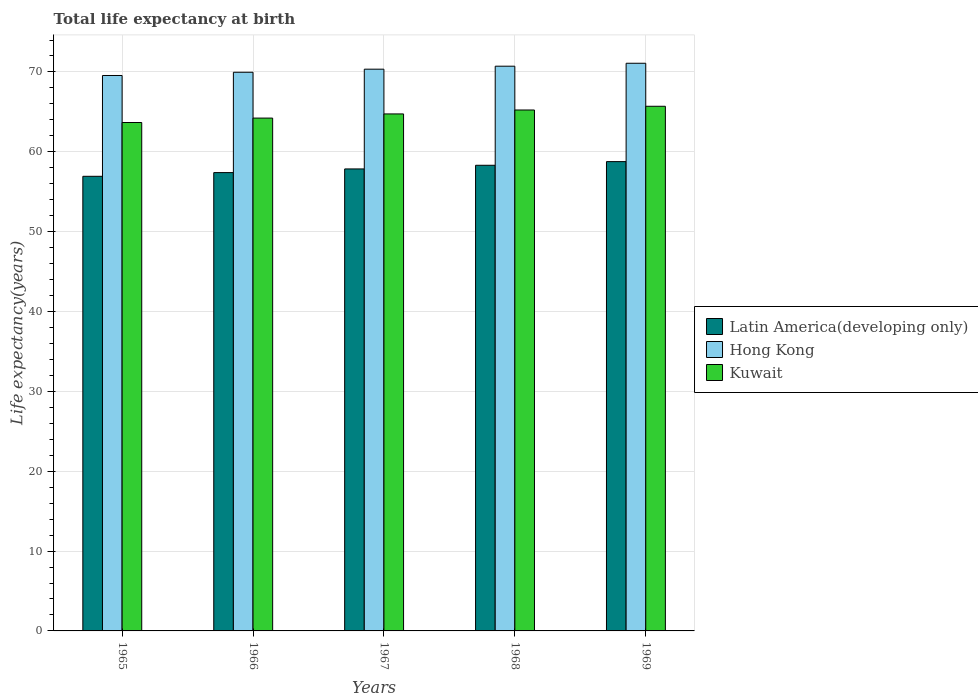How many different coloured bars are there?
Provide a succinct answer. 3. How many bars are there on the 2nd tick from the left?
Your response must be concise. 3. How many bars are there on the 5th tick from the right?
Provide a short and direct response. 3. What is the label of the 5th group of bars from the left?
Offer a terse response. 1969. What is the life expectancy at birth in in Kuwait in 1965?
Give a very brief answer. 63.67. Across all years, what is the maximum life expectancy at birth in in Kuwait?
Give a very brief answer. 65.7. Across all years, what is the minimum life expectancy at birth in in Hong Kong?
Make the answer very short. 69.56. In which year was the life expectancy at birth in in Hong Kong maximum?
Your answer should be compact. 1969. In which year was the life expectancy at birth in in Kuwait minimum?
Your answer should be very brief. 1965. What is the total life expectancy at birth in in Kuwait in the graph?
Keep it short and to the point. 323.57. What is the difference between the life expectancy at birth in in Kuwait in 1965 and that in 1969?
Keep it short and to the point. -2.03. What is the difference between the life expectancy at birth in in Hong Kong in 1968 and the life expectancy at birth in in Kuwait in 1969?
Ensure brevity in your answer.  5.02. What is the average life expectancy at birth in in Kuwait per year?
Provide a short and direct response. 64.71. In the year 1966, what is the difference between the life expectancy at birth in in Hong Kong and life expectancy at birth in in Kuwait?
Your answer should be very brief. 5.74. In how many years, is the life expectancy at birth in in Kuwait greater than 4 years?
Provide a succinct answer. 5. What is the ratio of the life expectancy at birth in in Latin America(developing only) in 1965 to that in 1969?
Provide a short and direct response. 0.97. Is the life expectancy at birth in in Hong Kong in 1967 less than that in 1968?
Provide a short and direct response. Yes. What is the difference between the highest and the second highest life expectancy at birth in in Kuwait?
Provide a short and direct response. 0.47. What is the difference between the highest and the lowest life expectancy at birth in in Latin America(developing only)?
Your response must be concise. 1.84. In how many years, is the life expectancy at birth in in Kuwait greater than the average life expectancy at birth in in Kuwait taken over all years?
Offer a very short reply. 3. Is the sum of the life expectancy at birth in in Latin America(developing only) in 1965 and 1967 greater than the maximum life expectancy at birth in in Hong Kong across all years?
Your response must be concise. Yes. What does the 1st bar from the left in 1968 represents?
Keep it short and to the point. Latin America(developing only). What does the 1st bar from the right in 1968 represents?
Provide a succinct answer. Kuwait. Is it the case that in every year, the sum of the life expectancy at birth in in Latin America(developing only) and life expectancy at birth in in Hong Kong is greater than the life expectancy at birth in in Kuwait?
Your response must be concise. Yes. Are all the bars in the graph horizontal?
Give a very brief answer. No. How many years are there in the graph?
Make the answer very short. 5. Are the values on the major ticks of Y-axis written in scientific E-notation?
Give a very brief answer. No. How many legend labels are there?
Offer a very short reply. 3. How are the legend labels stacked?
Your answer should be compact. Vertical. What is the title of the graph?
Make the answer very short. Total life expectancy at birth. What is the label or title of the X-axis?
Offer a terse response. Years. What is the label or title of the Y-axis?
Your answer should be compact. Life expectancy(years). What is the Life expectancy(years) in Latin America(developing only) in 1965?
Your answer should be compact. 56.93. What is the Life expectancy(years) of Hong Kong in 1965?
Ensure brevity in your answer.  69.56. What is the Life expectancy(years) of Kuwait in 1965?
Ensure brevity in your answer.  63.67. What is the Life expectancy(years) of Latin America(developing only) in 1966?
Provide a short and direct response. 57.39. What is the Life expectancy(years) of Hong Kong in 1966?
Give a very brief answer. 69.96. What is the Life expectancy(years) of Kuwait in 1966?
Your response must be concise. 64.22. What is the Life expectancy(years) in Latin America(developing only) in 1967?
Your answer should be very brief. 57.85. What is the Life expectancy(years) in Hong Kong in 1967?
Your response must be concise. 70.35. What is the Life expectancy(years) of Kuwait in 1967?
Make the answer very short. 64.74. What is the Life expectancy(years) in Latin America(developing only) in 1968?
Your answer should be compact. 58.31. What is the Life expectancy(years) in Hong Kong in 1968?
Make the answer very short. 70.72. What is the Life expectancy(years) of Kuwait in 1968?
Keep it short and to the point. 65.24. What is the Life expectancy(years) of Latin America(developing only) in 1969?
Ensure brevity in your answer.  58.77. What is the Life expectancy(years) in Hong Kong in 1969?
Provide a short and direct response. 71.09. What is the Life expectancy(years) in Kuwait in 1969?
Provide a short and direct response. 65.7. Across all years, what is the maximum Life expectancy(years) in Latin America(developing only)?
Ensure brevity in your answer.  58.77. Across all years, what is the maximum Life expectancy(years) in Hong Kong?
Offer a very short reply. 71.09. Across all years, what is the maximum Life expectancy(years) in Kuwait?
Provide a short and direct response. 65.7. Across all years, what is the minimum Life expectancy(years) in Latin America(developing only)?
Provide a short and direct response. 56.93. Across all years, what is the minimum Life expectancy(years) in Hong Kong?
Provide a succinct answer. 69.56. Across all years, what is the minimum Life expectancy(years) of Kuwait?
Give a very brief answer. 63.67. What is the total Life expectancy(years) of Latin America(developing only) in the graph?
Your answer should be very brief. 289.26. What is the total Life expectancy(years) of Hong Kong in the graph?
Your answer should be very brief. 351.67. What is the total Life expectancy(years) in Kuwait in the graph?
Keep it short and to the point. 323.57. What is the difference between the Life expectancy(years) in Latin America(developing only) in 1965 and that in 1966?
Your answer should be very brief. -0.46. What is the difference between the Life expectancy(years) of Hong Kong in 1965 and that in 1966?
Provide a succinct answer. -0.41. What is the difference between the Life expectancy(years) in Kuwait in 1965 and that in 1966?
Your answer should be very brief. -0.55. What is the difference between the Life expectancy(years) in Latin America(developing only) in 1965 and that in 1967?
Make the answer very short. -0.92. What is the difference between the Life expectancy(years) of Hong Kong in 1965 and that in 1967?
Give a very brief answer. -0.79. What is the difference between the Life expectancy(years) of Kuwait in 1965 and that in 1967?
Provide a succinct answer. -1.07. What is the difference between the Life expectancy(years) in Latin America(developing only) in 1965 and that in 1968?
Offer a terse response. -1.38. What is the difference between the Life expectancy(years) of Hong Kong in 1965 and that in 1968?
Make the answer very short. -1.16. What is the difference between the Life expectancy(years) of Kuwait in 1965 and that in 1968?
Give a very brief answer. -1.57. What is the difference between the Life expectancy(years) in Latin America(developing only) in 1965 and that in 1969?
Your response must be concise. -1.84. What is the difference between the Life expectancy(years) in Hong Kong in 1965 and that in 1969?
Keep it short and to the point. -1.53. What is the difference between the Life expectancy(years) in Kuwait in 1965 and that in 1969?
Make the answer very short. -2.03. What is the difference between the Life expectancy(years) of Latin America(developing only) in 1966 and that in 1967?
Offer a terse response. -0.46. What is the difference between the Life expectancy(years) of Hong Kong in 1966 and that in 1967?
Keep it short and to the point. -0.39. What is the difference between the Life expectancy(years) in Kuwait in 1966 and that in 1967?
Ensure brevity in your answer.  -0.52. What is the difference between the Life expectancy(years) of Latin America(developing only) in 1966 and that in 1968?
Give a very brief answer. -0.92. What is the difference between the Life expectancy(years) of Hong Kong in 1966 and that in 1968?
Make the answer very short. -0.76. What is the difference between the Life expectancy(years) of Kuwait in 1966 and that in 1968?
Your answer should be very brief. -1.01. What is the difference between the Life expectancy(years) of Latin America(developing only) in 1966 and that in 1969?
Ensure brevity in your answer.  -1.38. What is the difference between the Life expectancy(years) of Hong Kong in 1966 and that in 1969?
Make the answer very short. -1.13. What is the difference between the Life expectancy(years) in Kuwait in 1966 and that in 1969?
Offer a terse response. -1.48. What is the difference between the Life expectancy(years) in Latin America(developing only) in 1967 and that in 1968?
Your answer should be compact. -0.46. What is the difference between the Life expectancy(years) in Hong Kong in 1967 and that in 1968?
Give a very brief answer. -0.37. What is the difference between the Life expectancy(years) in Kuwait in 1967 and that in 1968?
Give a very brief answer. -0.49. What is the difference between the Life expectancy(years) in Latin America(developing only) in 1967 and that in 1969?
Provide a succinct answer. -0.92. What is the difference between the Life expectancy(years) in Hong Kong in 1967 and that in 1969?
Give a very brief answer. -0.74. What is the difference between the Life expectancy(years) of Kuwait in 1967 and that in 1969?
Provide a short and direct response. -0.96. What is the difference between the Life expectancy(years) in Latin America(developing only) in 1968 and that in 1969?
Provide a succinct answer. -0.46. What is the difference between the Life expectancy(years) in Hong Kong in 1968 and that in 1969?
Provide a short and direct response. -0.37. What is the difference between the Life expectancy(years) in Kuwait in 1968 and that in 1969?
Your response must be concise. -0.47. What is the difference between the Life expectancy(years) of Latin America(developing only) in 1965 and the Life expectancy(years) of Hong Kong in 1966?
Offer a very short reply. -13.03. What is the difference between the Life expectancy(years) of Latin America(developing only) in 1965 and the Life expectancy(years) of Kuwait in 1966?
Provide a succinct answer. -7.29. What is the difference between the Life expectancy(years) of Hong Kong in 1965 and the Life expectancy(years) of Kuwait in 1966?
Offer a very short reply. 5.33. What is the difference between the Life expectancy(years) of Latin America(developing only) in 1965 and the Life expectancy(years) of Hong Kong in 1967?
Give a very brief answer. -13.42. What is the difference between the Life expectancy(years) of Latin America(developing only) in 1965 and the Life expectancy(years) of Kuwait in 1967?
Your answer should be compact. -7.81. What is the difference between the Life expectancy(years) of Hong Kong in 1965 and the Life expectancy(years) of Kuwait in 1967?
Your answer should be compact. 4.81. What is the difference between the Life expectancy(years) of Latin America(developing only) in 1965 and the Life expectancy(years) of Hong Kong in 1968?
Offer a very short reply. -13.79. What is the difference between the Life expectancy(years) in Latin America(developing only) in 1965 and the Life expectancy(years) in Kuwait in 1968?
Give a very brief answer. -8.3. What is the difference between the Life expectancy(years) of Hong Kong in 1965 and the Life expectancy(years) of Kuwait in 1968?
Your answer should be compact. 4.32. What is the difference between the Life expectancy(years) of Latin America(developing only) in 1965 and the Life expectancy(years) of Hong Kong in 1969?
Ensure brevity in your answer.  -14.16. What is the difference between the Life expectancy(years) of Latin America(developing only) in 1965 and the Life expectancy(years) of Kuwait in 1969?
Ensure brevity in your answer.  -8.77. What is the difference between the Life expectancy(years) of Hong Kong in 1965 and the Life expectancy(years) of Kuwait in 1969?
Give a very brief answer. 3.85. What is the difference between the Life expectancy(years) in Latin America(developing only) in 1966 and the Life expectancy(years) in Hong Kong in 1967?
Offer a terse response. -12.95. What is the difference between the Life expectancy(years) in Latin America(developing only) in 1966 and the Life expectancy(years) in Kuwait in 1967?
Offer a very short reply. -7.35. What is the difference between the Life expectancy(years) in Hong Kong in 1966 and the Life expectancy(years) in Kuwait in 1967?
Make the answer very short. 5.22. What is the difference between the Life expectancy(years) of Latin America(developing only) in 1966 and the Life expectancy(years) of Hong Kong in 1968?
Give a very brief answer. -13.33. What is the difference between the Life expectancy(years) of Latin America(developing only) in 1966 and the Life expectancy(years) of Kuwait in 1968?
Give a very brief answer. -7.84. What is the difference between the Life expectancy(years) in Hong Kong in 1966 and the Life expectancy(years) in Kuwait in 1968?
Give a very brief answer. 4.73. What is the difference between the Life expectancy(years) in Latin America(developing only) in 1966 and the Life expectancy(years) in Hong Kong in 1969?
Your answer should be very brief. -13.69. What is the difference between the Life expectancy(years) in Latin America(developing only) in 1966 and the Life expectancy(years) in Kuwait in 1969?
Keep it short and to the point. -8.31. What is the difference between the Life expectancy(years) of Hong Kong in 1966 and the Life expectancy(years) of Kuwait in 1969?
Keep it short and to the point. 4.26. What is the difference between the Life expectancy(years) in Latin America(developing only) in 1967 and the Life expectancy(years) in Hong Kong in 1968?
Make the answer very short. -12.87. What is the difference between the Life expectancy(years) of Latin America(developing only) in 1967 and the Life expectancy(years) of Kuwait in 1968?
Your answer should be very brief. -7.38. What is the difference between the Life expectancy(years) in Hong Kong in 1967 and the Life expectancy(years) in Kuwait in 1968?
Your response must be concise. 5.11. What is the difference between the Life expectancy(years) in Latin America(developing only) in 1967 and the Life expectancy(years) in Hong Kong in 1969?
Offer a very short reply. -13.23. What is the difference between the Life expectancy(years) of Latin America(developing only) in 1967 and the Life expectancy(years) of Kuwait in 1969?
Make the answer very short. -7.85. What is the difference between the Life expectancy(years) of Hong Kong in 1967 and the Life expectancy(years) of Kuwait in 1969?
Provide a succinct answer. 4.65. What is the difference between the Life expectancy(years) in Latin America(developing only) in 1968 and the Life expectancy(years) in Hong Kong in 1969?
Provide a short and direct response. -12.77. What is the difference between the Life expectancy(years) in Latin America(developing only) in 1968 and the Life expectancy(years) in Kuwait in 1969?
Your answer should be very brief. -7.39. What is the difference between the Life expectancy(years) of Hong Kong in 1968 and the Life expectancy(years) of Kuwait in 1969?
Your response must be concise. 5.02. What is the average Life expectancy(years) in Latin America(developing only) per year?
Your answer should be very brief. 57.85. What is the average Life expectancy(years) in Hong Kong per year?
Your answer should be compact. 70.33. What is the average Life expectancy(years) in Kuwait per year?
Provide a succinct answer. 64.71. In the year 1965, what is the difference between the Life expectancy(years) in Latin America(developing only) and Life expectancy(years) in Hong Kong?
Keep it short and to the point. -12.62. In the year 1965, what is the difference between the Life expectancy(years) of Latin America(developing only) and Life expectancy(years) of Kuwait?
Offer a very short reply. -6.74. In the year 1965, what is the difference between the Life expectancy(years) of Hong Kong and Life expectancy(years) of Kuwait?
Ensure brevity in your answer.  5.89. In the year 1966, what is the difference between the Life expectancy(years) of Latin America(developing only) and Life expectancy(years) of Hong Kong?
Give a very brief answer. -12.57. In the year 1966, what is the difference between the Life expectancy(years) of Latin America(developing only) and Life expectancy(years) of Kuwait?
Provide a succinct answer. -6.83. In the year 1966, what is the difference between the Life expectancy(years) of Hong Kong and Life expectancy(years) of Kuwait?
Provide a succinct answer. 5.74. In the year 1967, what is the difference between the Life expectancy(years) of Latin America(developing only) and Life expectancy(years) of Hong Kong?
Keep it short and to the point. -12.49. In the year 1967, what is the difference between the Life expectancy(years) of Latin America(developing only) and Life expectancy(years) of Kuwait?
Your answer should be very brief. -6.89. In the year 1967, what is the difference between the Life expectancy(years) of Hong Kong and Life expectancy(years) of Kuwait?
Provide a succinct answer. 5.6. In the year 1968, what is the difference between the Life expectancy(years) in Latin America(developing only) and Life expectancy(years) in Hong Kong?
Provide a succinct answer. -12.41. In the year 1968, what is the difference between the Life expectancy(years) of Latin America(developing only) and Life expectancy(years) of Kuwait?
Make the answer very short. -6.92. In the year 1968, what is the difference between the Life expectancy(years) of Hong Kong and Life expectancy(years) of Kuwait?
Ensure brevity in your answer.  5.49. In the year 1969, what is the difference between the Life expectancy(years) of Latin America(developing only) and Life expectancy(years) of Hong Kong?
Ensure brevity in your answer.  -12.32. In the year 1969, what is the difference between the Life expectancy(years) in Latin America(developing only) and Life expectancy(years) in Kuwait?
Make the answer very short. -6.93. In the year 1969, what is the difference between the Life expectancy(years) in Hong Kong and Life expectancy(years) in Kuwait?
Give a very brief answer. 5.39. What is the ratio of the Life expectancy(years) in Latin America(developing only) in 1965 to that in 1966?
Your answer should be very brief. 0.99. What is the ratio of the Life expectancy(years) of Kuwait in 1965 to that in 1966?
Keep it short and to the point. 0.99. What is the ratio of the Life expectancy(years) of Hong Kong in 1965 to that in 1967?
Keep it short and to the point. 0.99. What is the ratio of the Life expectancy(years) of Kuwait in 1965 to that in 1967?
Keep it short and to the point. 0.98. What is the ratio of the Life expectancy(years) in Latin America(developing only) in 1965 to that in 1968?
Provide a short and direct response. 0.98. What is the ratio of the Life expectancy(years) in Hong Kong in 1965 to that in 1968?
Make the answer very short. 0.98. What is the ratio of the Life expectancy(years) in Latin America(developing only) in 1965 to that in 1969?
Ensure brevity in your answer.  0.97. What is the ratio of the Life expectancy(years) in Hong Kong in 1965 to that in 1969?
Your response must be concise. 0.98. What is the ratio of the Life expectancy(years) in Kuwait in 1965 to that in 1969?
Provide a succinct answer. 0.97. What is the ratio of the Life expectancy(years) of Latin America(developing only) in 1966 to that in 1968?
Make the answer very short. 0.98. What is the ratio of the Life expectancy(years) in Hong Kong in 1966 to that in 1968?
Ensure brevity in your answer.  0.99. What is the ratio of the Life expectancy(years) of Kuwait in 1966 to that in 1968?
Keep it short and to the point. 0.98. What is the ratio of the Life expectancy(years) in Latin America(developing only) in 1966 to that in 1969?
Your response must be concise. 0.98. What is the ratio of the Life expectancy(years) in Hong Kong in 1966 to that in 1969?
Ensure brevity in your answer.  0.98. What is the ratio of the Life expectancy(years) of Kuwait in 1966 to that in 1969?
Give a very brief answer. 0.98. What is the ratio of the Life expectancy(years) of Kuwait in 1967 to that in 1968?
Offer a terse response. 0.99. What is the ratio of the Life expectancy(years) in Latin America(developing only) in 1967 to that in 1969?
Your answer should be very brief. 0.98. What is the ratio of the Life expectancy(years) of Hong Kong in 1967 to that in 1969?
Make the answer very short. 0.99. What is the ratio of the Life expectancy(years) in Kuwait in 1967 to that in 1969?
Your response must be concise. 0.99. What is the ratio of the Life expectancy(years) of Latin America(developing only) in 1968 to that in 1969?
Provide a short and direct response. 0.99. What is the ratio of the Life expectancy(years) in Kuwait in 1968 to that in 1969?
Your answer should be very brief. 0.99. What is the difference between the highest and the second highest Life expectancy(years) in Latin America(developing only)?
Give a very brief answer. 0.46. What is the difference between the highest and the second highest Life expectancy(years) in Hong Kong?
Keep it short and to the point. 0.37. What is the difference between the highest and the second highest Life expectancy(years) in Kuwait?
Offer a very short reply. 0.47. What is the difference between the highest and the lowest Life expectancy(years) in Latin America(developing only)?
Your response must be concise. 1.84. What is the difference between the highest and the lowest Life expectancy(years) in Hong Kong?
Your response must be concise. 1.53. What is the difference between the highest and the lowest Life expectancy(years) in Kuwait?
Give a very brief answer. 2.03. 